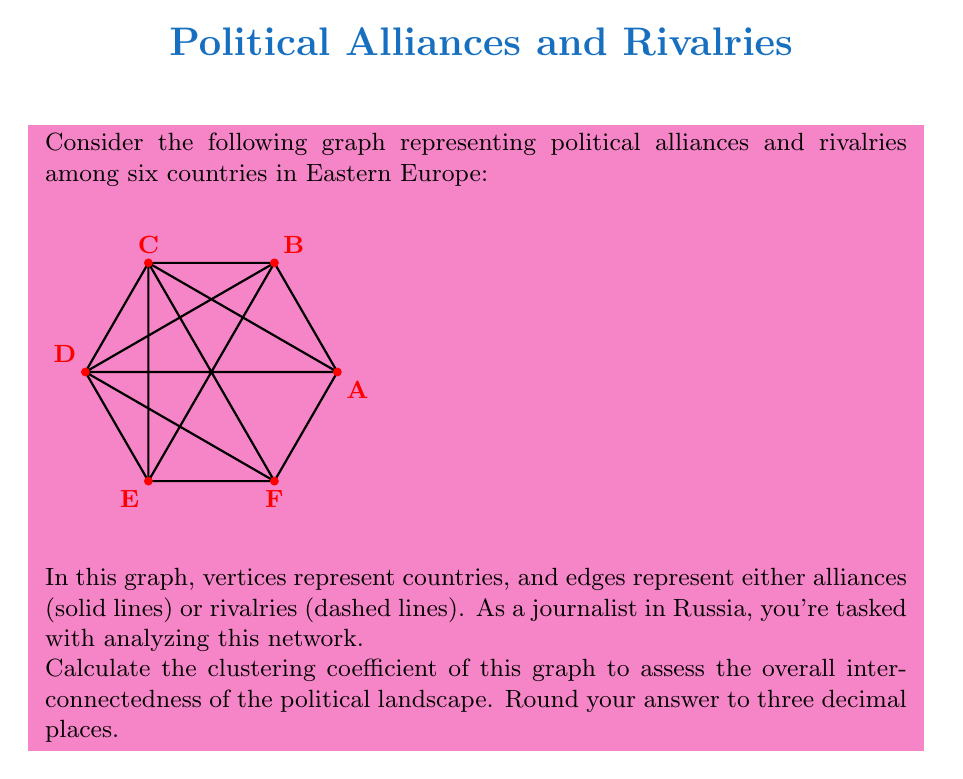Teach me how to tackle this problem. To calculate the clustering coefficient of the graph, we need to follow these steps:

1) The clustering coefficient is defined as:

   $$ C = \frac{3 \times \text{number of triangles}}{\text{number of connected triples}} $$

2) First, let's count the number of triangles in the graph:
   ABC, ACD, ADF, BCD, BDE, CEF, DEF

   There are 7 triangles.

3) Now, let's count the number of connected triples. A connected triple is a set of three vertices where at least two edges connect them. For each vertex, we need to calculate $\binom{k}{2}$, where $k$ is the degree of the vertex:

   A: degree 4, $\binom{4}{2} = 6$
   B: degree 4, $\binom{4}{2} = 6$
   C: degree 5, $\binom{5}{2} = 10$
   D: degree 5, $\binom{5}{2} = 10$
   E: degree 4, $\binom{4}{2} = 6$
   F: degree 4, $\binom{4}{2} = 6$

   Total: 6 + 6 + 10 + 10 + 6 + 6 = 44

4) Now we can calculate the clustering coefficient:

   $$ C = \frac{3 \times 7}{44} = \frac{21}{44} \approx 0.477 $$

5) Rounding to three decimal places: 0.477

This relatively high clustering coefficient indicates a densely interconnected political landscape, suggesting complex relationships and potential for both cooperation and conflict among these Eastern European countries.
Answer: 0.477 